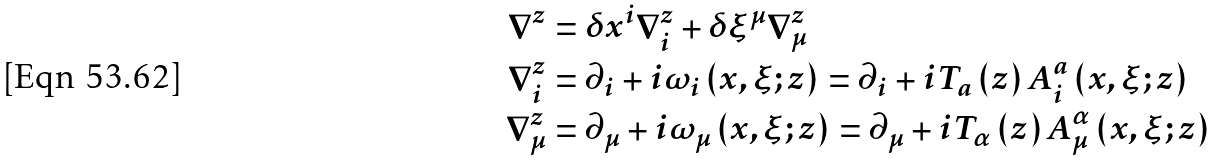Convert formula to latex. <formula><loc_0><loc_0><loc_500><loc_500>\nabla ^ { z } & = \delta x ^ { i } \nabla _ { i } ^ { z } + \delta \xi ^ { \mu } \nabla _ { \mu } ^ { z } \\ \nabla _ { i } ^ { z } & = \partial _ { i } + i \omega _ { i } \left ( x , \xi ; z \right ) = \partial _ { i } + i T _ { a } \left ( z \right ) A _ { i } ^ { a } \left ( x , \xi ; z \right ) \\ \nabla _ { \mu } ^ { z } & = \partial _ { \mu } + i \omega _ { \mu } \left ( x , \xi ; z \right ) = \partial _ { \mu } + i T _ { \alpha } \left ( z \right ) A _ { \mu } ^ { \alpha } \left ( x , \xi ; z \right )</formula> 